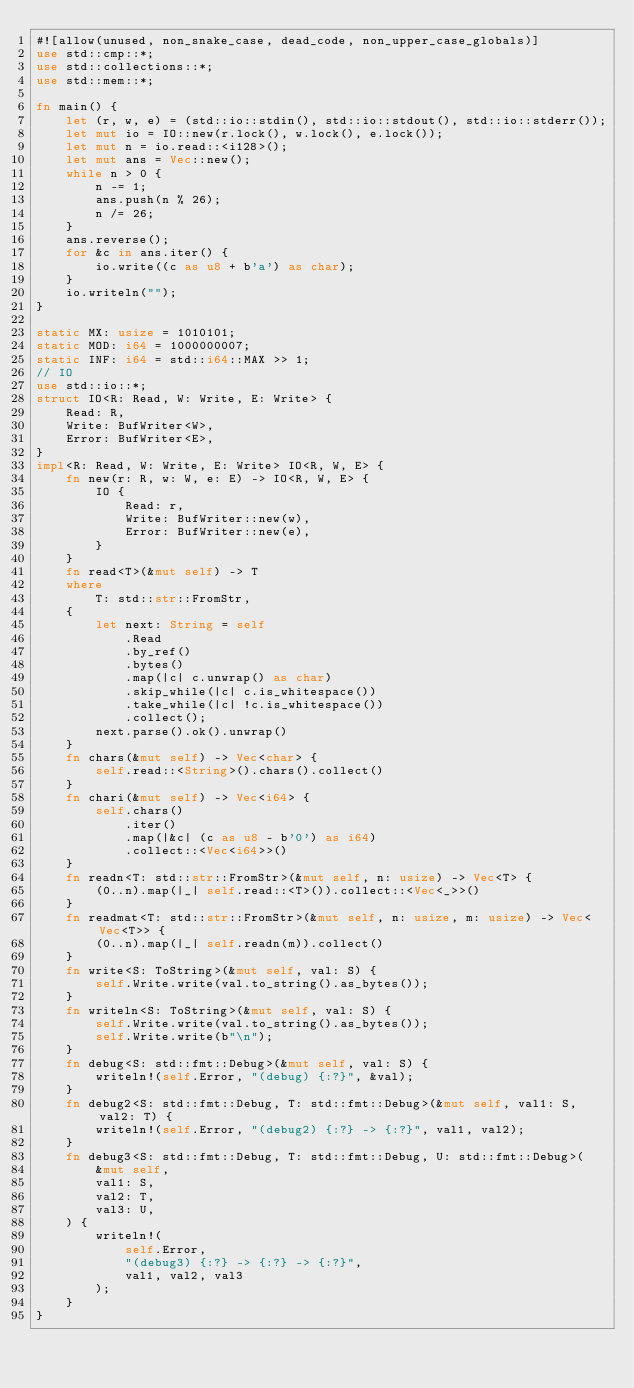Convert code to text. <code><loc_0><loc_0><loc_500><loc_500><_Rust_>#![allow(unused, non_snake_case, dead_code, non_upper_case_globals)]
use std::cmp::*;
use std::collections::*;
use std::mem::*;

fn main() {
    let (r, w, e) = (std::io::stdin(), std::io::stdout(), std::io::stderr());
    let mut io = IO::new(r.lock(), w.lock(), e.lock());
    let mut n = io.read::<i128>();
    let mut ans = Vec::new();
    while n > 0 {
        n -= 1;
        ans.push(n % 26);
        n /= 26;
    }
    ans.reverse();
    for &c in ans.iter() {
        io.write((c as u8 + b'a') as char);
    }
    io.writeln("");
}

static MX: usize = 1010101;
static MOD: i64 = 1000000007;
static INF: i64 = std::i64::MAX >> 1;
// IO
use std::io::*;
struct IO<R: Read, W: Write, E: Write> {
    Read: R,
    Write: BufWriter<W>,
    Error: BufWriter<E>,
}
impl<R: Read, W: Write, E: Write> IO<R, W, E> {
    fn new(r: R, w: W, e: E) -> IO<R, W, E> {
        IO {
            Read: r,
            Write: BufWriter::new(w),
            Error: BufWriter::new(e),
        }
    }
    fn read<T>(&mut self) -> T
    where
        T: std::str::FromStr,
    {
        let next: String = self
            .Read
            .by_ref()
            .bytes()
            .map(|c| c.unwrap() as char)
            .skip_while(|c| c.is_whitespace())
            .take_while(|c| !c.is_whitespace())
            .collect();
        next.parse().ok().unwrap()
    }
    fn chars(&mut self) -> Vec<char> {
        self.read::<String>().chars().collect()
    }
    fn chari(&mut self) -> Vec<i64> {
        self.chars()
            .iter()
            .map(|&c| (c as u8 - b'0') as i64)
            .collect::<Vec<i64>>()
    }
    fn readn<T: std::str::FromStr>(&mut self, n: usize) -> Vec<T> {
        (0..n).map(|_| self.read::<T>()).collect::<Vec<_>>()
    }
    fn readmat<T: std::str::FromStr>(&mut self, n: usize, m: usize) -> Vec<Vec<T>> {
        (0..n).map(|_| self.readn(m)).collect()
    }
    fn write<S: ToString>(&mut self, val: S) {
        self.Write.write(val.to_string().as_bytes());
    }
    fn writeln<S: ToString>(&mut self, val: S) {
        self.Write.write(val.to_string().as_bytes());
        self.Write.write(b"\n");
    }
    fn debug<S: std::fmt::Debug>(&mut self, val: S) {
        writeln!(self.Error, "(debug) {:?}", &val);
    }
    fn debug2<S: std::fmt::Debug, T: std::fmt::Debug>(&mut self, val1: S, val2: T) {
        writeln!(self.Error, "(debug2) {:?} -> {:?}", val1, val2);
    }
    fn debug3<S: std::fmt::Debug, T: std::fmt::Debug, U: std::fmt::Debug>(
        &mut self,
        val1: S,
        val2: T,
        val3: U,
    ) {
        writeln!(
            self.Error,
            "(debug3) {:?} -> {:?} -> {:?}",
            val1, val2, val3
        );
    }
}
</code> 